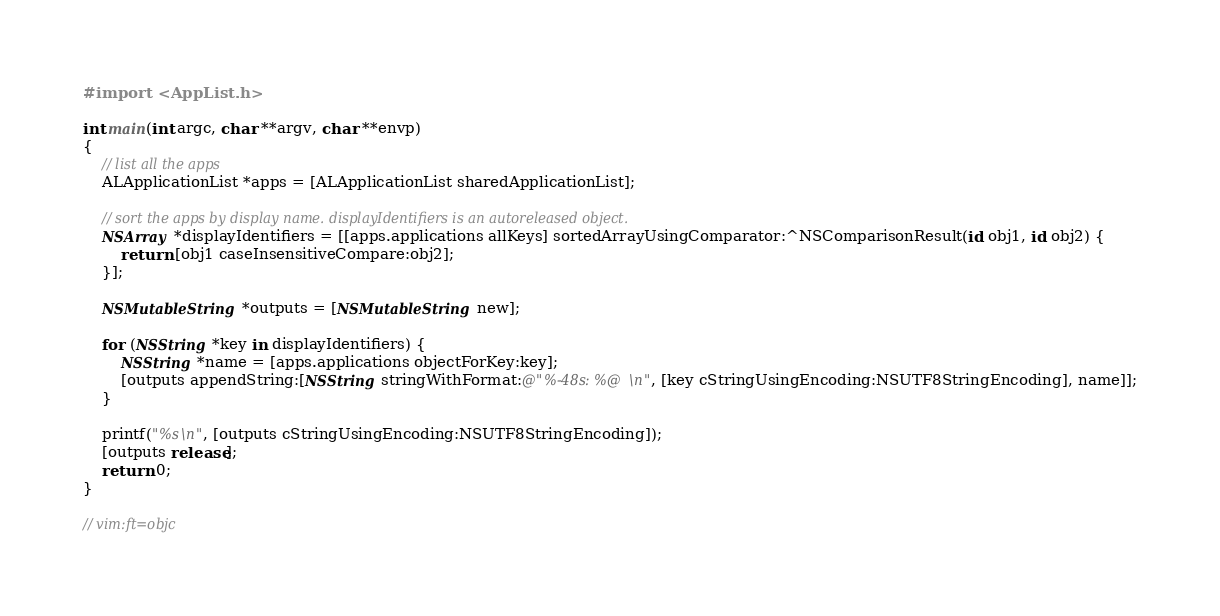<code> <loc_0><loc_0><loc_500><loc_500><_ObjectiveC_>#import <AppList.h>

int main(int argc, char **argv, char **envp)
{
    // list all the apps
    ALApplicationList *apps = [ALApplicationList sharedApplicationList];
    
    // sort the apps by display name. displayIdentifiers is an autoreleased object.
    NSArray *displayIdentifiers = [[apps.applications allKeys] sortedArrayUsingComparator:^NSComparisonResult(id obj1, id obj2) {
        return [obj1 caseInsensitiveCompare:obj2];
    }];
    
    NSMutableString *outputs = [NSMutableString new];
    
    for (NSString *key in displayIdentifiers) {
        NSString *name = [apps.applications objectForKey:key];
        [outputs appendString:[NSString stringWithFormat:@"%-48s: %@\n", [key cStringUsingEncoding:NSUTF8StringEncoding], name]];
    }
    
    printf("%s\n", [outputs cStringUsingEncoding:NSUTF8StringEncoding]);
    [outputs release];
	return 0;
}

// vim:ft=objc
</code> 